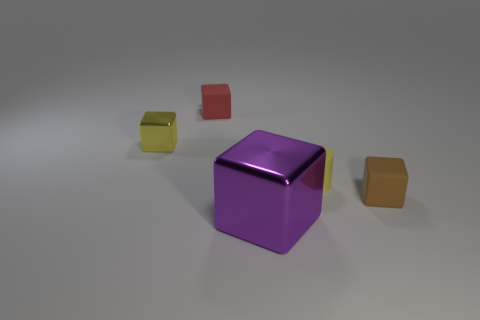Subtract all purple blocks. How many blocks are left? 3 Add 4 brown rubber cylinders. How many objects exist? 9 Subtract all blocks. How many objects are left? 1 Subtract all brown blocks. How many blocks are left? 3 Subtract 2 blocks. How many blocks are left? 2 Subtract all brown cubes. Subtract all gray cylinders. How many cubes are left? 3 Subtract all tiny yellow matte cylinders. Subtract all big metal cubes. How many objects are left? 3 Add 1 large blocks. How many large blocks are left? 2 Add 3 tiny red things. How many tiny red things exist? 4 Subtract 0 cyan blocks. How many objects are left? 5 